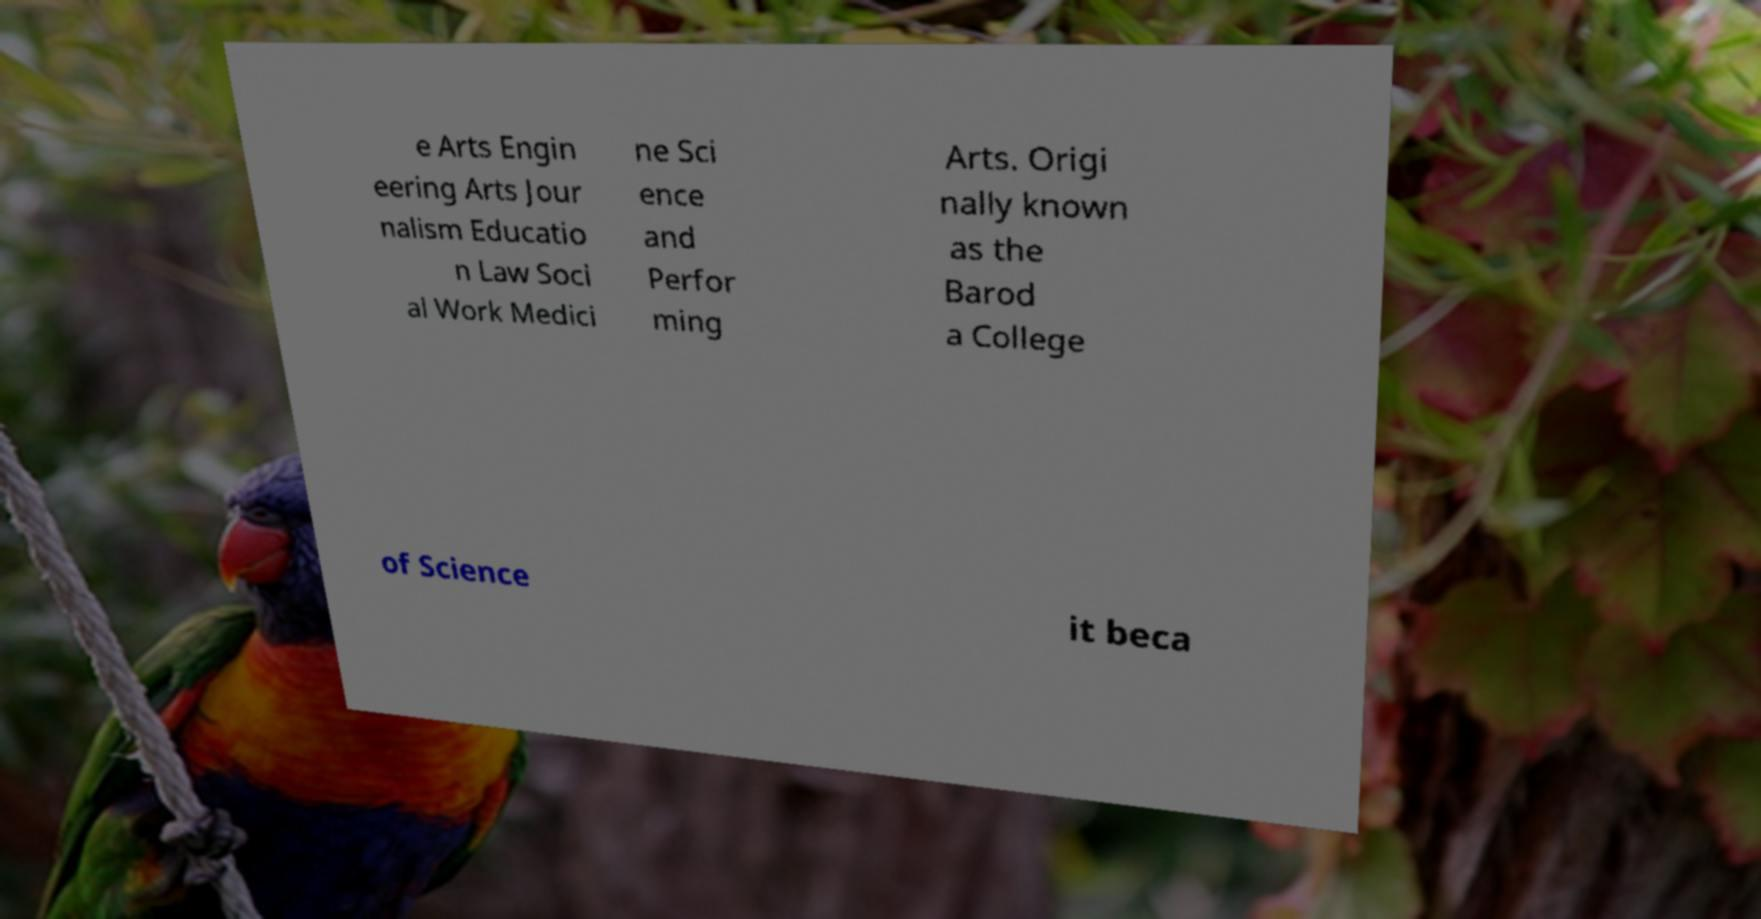Could you assist in decoding the text presented in this image and type it out clearly? e Arts Engin eering Arts Jour nalism Educatio n Law Soci al Work Medici ne Sci ence and Perfor ming Arts. Origi nally known as the Barod a College of Science it beca 